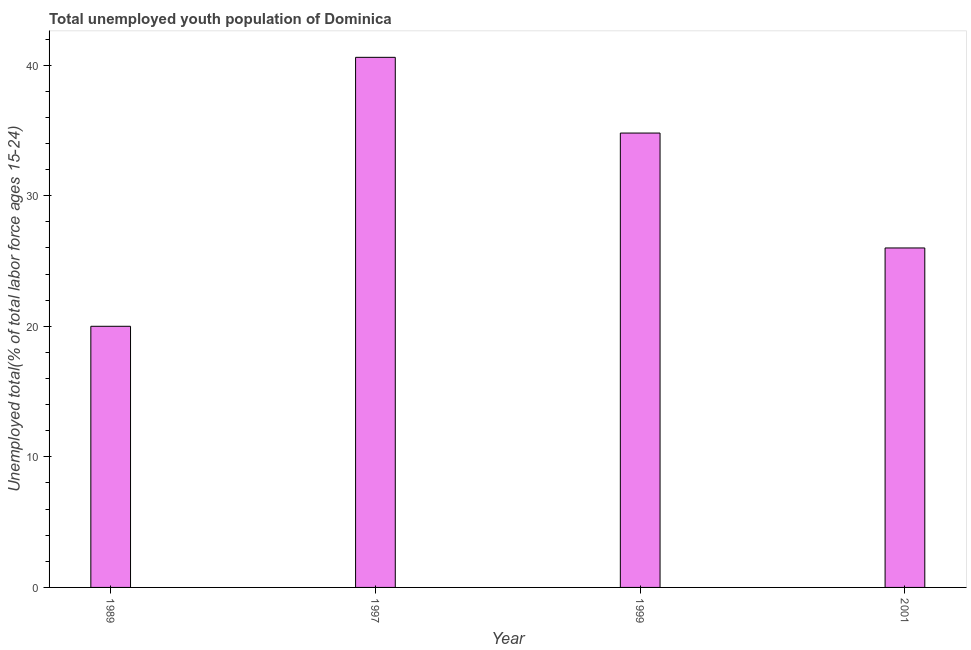Does the graph contain any zero values?
Give a very brief answer. No. What is the title of the graph?
Your answer should be compact. Total unemployed youth population of Dominica. What is the label or title of the X-axis?
Make the answer very short. Year. What is the label or title of the Y-axis?
Provide a short and direct response. Unemployed total(% of total labor force ages 15-24). What is the unemployed youth in 2001?
Your answer should be compact. 26. Across all years, what is the maximum unemployed youth?
Your response must be concise. 40.6. Across all years, what is the minimum unemployed youth?
Ensure brevity in your answer.  20. What is the sum of the unemployed youth?
Give a very brief answer. 121.4. What is the difference between the unemployed youth in 1989 and 1997?
Your response must be concise. -20.6. What is the average unemployed youth per year?
Provide a succinct answer. 30.35. What is the median unemployed youth?
Ensure brevity in your answer.  30.4. Do a majority of the years between 2001 and 1989 (inclusive) have unemployed youth greater than 6 %?
Provide a succinct answer. Yes. What is the ratio of the unemployed youth in 1997 to that in 1999?
Provide a short and direct response. 1.17. Is the difference between the unemployed youth in 1999 and 2001 greater than the difference between any two years?
Make the answer very short. No. What is the difference between the highest and the lowest unemployed youth?
Make the answer very short. 20.6. How many bars are there?
Keep it short and to the point. 4. Are all the bars in the graph horizontal?
Keep it short and to the point. No. Are the values on the major ticks of Y-axis written in scientific E-notation?
Your answer should be compact. No. What is the Unemployed total(% of total labor force ages 15-24) in 1989?
Give a very brief answer. 20. What is the Unemployed total(% of total labor force ages 15-24) in 1997?
Your response must be concise. 40.6. What is the Unemployed total(% of total labor force ages 15-24) of 1999?
Your response must be concise. 34.8. What is the difference between the Unemployed total(% of total labor force ages 15-24) in 1989 and 1997?
Make the answer very short. -20.6. What is the difference between the Unemployed total(% of total labor force ages 15-24) in 1989 and 1999?
Offer a very short reply. -14.8. What is the difference between the Unemployed total(% of total labor force ages 15-24) in 1989 and 2001?
Give a very brief answer. -6. What is the difference between the Unemployed total(% of total labor force ages 15-24) in 1999 and 2001?
Your answer should be very brief. 8.8. What is the ratio of the Unemployed total(% of total labor force ages 15-24) in 1989 to that in 1997?
Offer a very short reply. 0.49. What is the ratio of the Unemployed total(% of total labor force ages 15-24) in 1989 to that in 1999?
Make the answer very short. 0.57. What is the ratio of the Unemployed total(% of total labor force ages 15-24) in 1989 to that in 2001?
Your response must be concise. 0.77. What is the ratio of the Unemployed total(% of total labor force ages 15-24) in 1997 to that in 1999?
Your answer should be very brief. 1.17. What is the ratio of the Unemployed total(% of total labor force ages 15-24) in 1997 to that in 2001?
Provide a short and direct response. 1.56. What is the ratio of the Unemployed total(% of total labor force ages 15-24) in 1999 to that in 2001?
Provide a succinct answer. 1.34. 